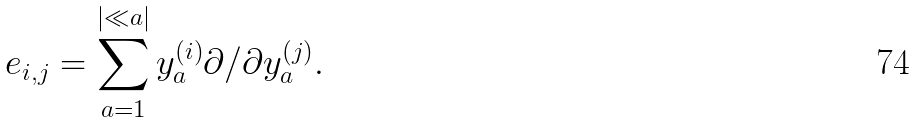<formula> <loc_0><loc_0><loc_500><loc_500>e _ { i , j } = \sum _ { a = 1 } ^ { | \ll a | } y ^ { ( i ) } _ { a } \partial / \partial y ^ { ( j ) } _ { a } .</formula> 